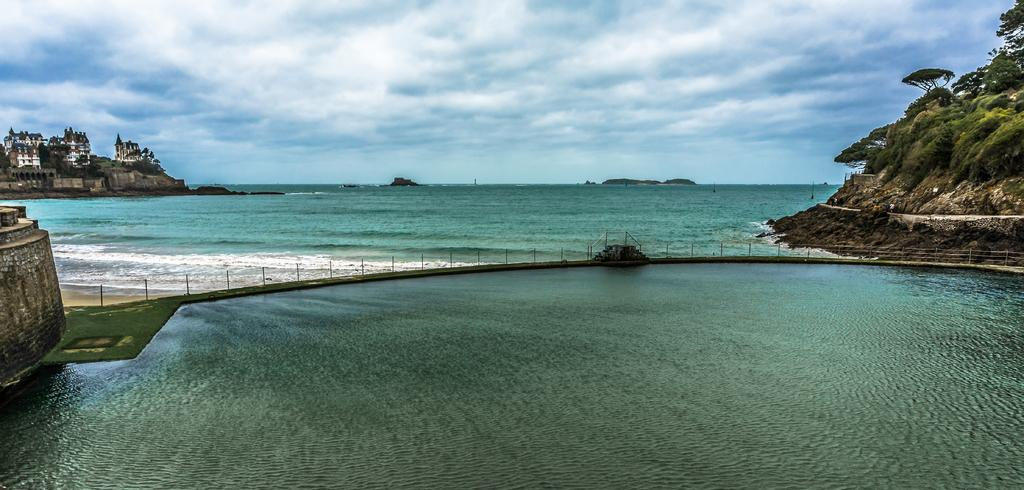What is the primary element visible in the image? There is water in the image. What structure can be seen crossing over the water? There is a bridge in the image. What other structures can be seen in the image? There is a wall and buildings in the image. What type of vegetation is present in the image? There are trees in the image. What natural feature is visible in the background of the image? There is a mountain in the image. What is visible in the sky in the image? The sky is visible in the background of the image, and there are clouds in the sky. What type of copper knot can be seen floating in the water in the image? There is no copper knot present in the image; it is a water scene with a bridge, wall, buildings, trees, a mountain, and clouds in the sky. 